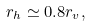Convert formula to latex. <formula><loc_0><loc_0><loc_500><loc_500>r _ { h } \simeq 0 . 8 r _ { v } ,</formula> 